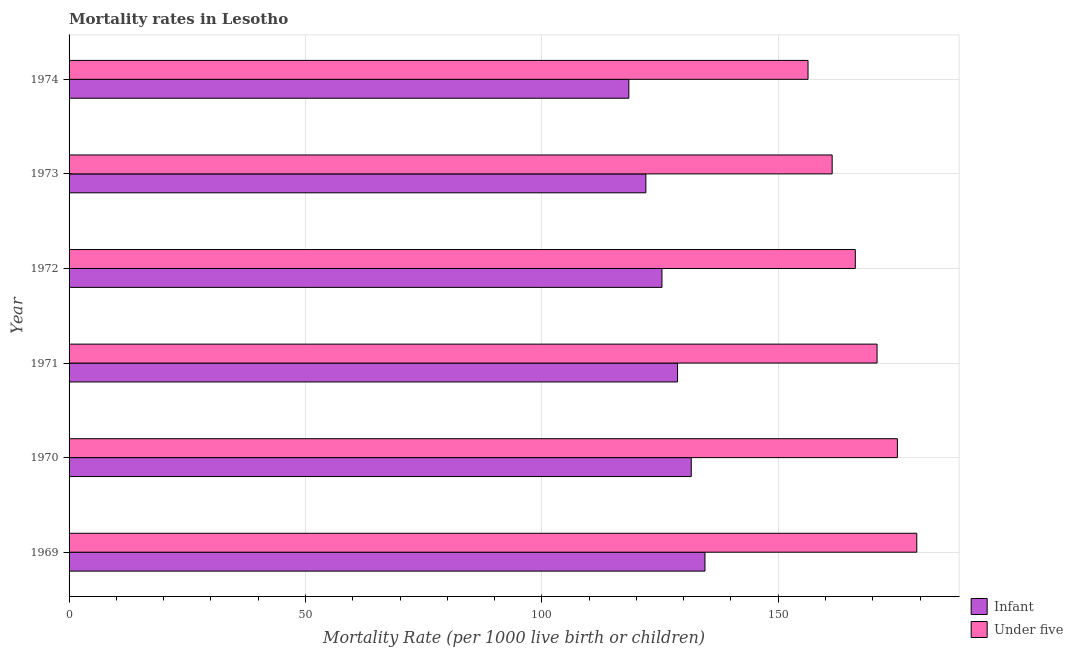Are the number of bars per tick equal to the number of legend labels?
Offer a very short reply. Yes. How many bars are there on the 1st tick from the top?
Offer a very short reply. 2. How many bars are there on the 5th tick from the bottom?
Provide a short and direct response. 2. What is the label of the 1st group of bars from the top?
Provide a short and direct response. 1974. What is the infant mortality rate in 1969?
Ensure brevity in your answer.  134.5. Across all years, what is the maximum under-5 mortality rate?
Offer a terse response. 179.3. Across all years, what is the minimum infant mortality rate?
Offer a terse response. 118.4. In which year was the under-5 mortality rate maximum?
Your answer should be very brief. 1969. In which year was the infant mortality rate minimum?
Your response must be concise. 1974. What is the total infant mortality rate in the graph?
Your answer should be very brief. 760.6. What is the difference between the under-5 mortality rate in 1971 and that in 1972?
Give a very brief answer. 4.6. What is the difference between the under-5 mortality rate in 1969 and the infant mortality rate in 1970?
Make the answer very short. 47.7. What is the average infant mortality rate per year?
Give a very brief answer. 126.77. In the year 1973, what is the difference between the infant mortality rate and under-5 mortality rate?
Provide a succinct answer. -39.4. In how many years, is the infant mortality rate greater than 160 ?
Provide a succinct answer. 0. What is the ratio of the infant mortality rate in 1969 to that in 1974?
Offer a terse response. 1.14. Is the under-5 mortality rate in 1972 less than that in 1973?
Offer a terse response. No. Is the difference between the under-5 mortality rate in 1972 and 1974 greater than the difference between the infant mortality rate in 1972 and 1974?
Offer a terse response. Yes. What is the difference between the highest and the second highest infant mortality rate?
Make the answer very short. 2.9. In how many years, is the under-5 mortality rate greater than the average under-5 mortality rate taken over all years?
Give a very brief answer. 3. What does the 1st bar from the top in 1973 represents?
Offer a terse response. Under five. What does the 2nd bar from the bottom in 1969 represents?
Your response must be concise. Under five. Are all the bars in the graph horizontal?
Your answer should be very brief. Yes. How many years are there in the graph?
Ensure brevity in your answer.  6. What is the difference between two consecutive major ticks on the X-axis?
Ensure brevity in your answer.  50. Does the graph contain any zero values?
Provide a succinct answer. No. Does the graph contain grids?
Offer a very short reply. Yes. Where does the legend appear in the graph?
Offer a terse response. Bottom right. How many legend labels are there?
Your answer should be very brief. 2. How are the legend labels stacked?
Provide a succinct answer. Vertical. What is the title of the graph?
Make the answer very short. Mortality rates in Lesotho. What is the label or title of the X-axis?
Your answer should be very brief. Mortality Rate (per 1000 live birth or children). What is the Mortality Rate (per 1000 live birth or children) in Infant in 1969?
Offer a terse response. 134.5. What is the Mortality Rate (per 1000 live birth or children) of Under five in 1969?
Offer a terse response. 179.3. What is the Mortality Rate (per 1000 live birth or children) in Infant in 1970?
Make the answer very short. 131.6. What is the Mortality Rate (per 1000 live birth or children) in Under five in 1970?
Ensure brevity in your answer.  175.2. What is the Mortality Rate (per 1000 live birth or children) of Infant in 1971?
Keep it short and to the point. 128.7. What is the Mortality Rate (per 1000 live birth or children) in Under five in 1971?
Ensure brevity in your answer.  170.9. What is the Mortality Rate (per 1000 live birth or children) in Infant in 1972?
Your response must be concise. 125.4. What is the Mortality Rate (per 1000 live birth or children) in Under five in 1972?
Offer a very short reply. 166.3. What is the Mortality Rate (per 1000 live birth or children) in Infant in 1973?
Your answer should be compact. 122. What is the Mortality Rate (per 1000 live birth or children) in Under five in 1973?
Your answer should be very brief. 161.4. What is the Mortality Rate (per 1000 live birth or children) in Infant in 1974?
Keep it short and to the point. 118.4. What is the Mortality Rate (per 1000 live birth or children) in Under five in 1974?
Offer a terse response. 156.3. Across all years, what is the maximum Mortality Rate (per 1000 live birth or children) of Infant?
Keep it short and to the point. 134.5. Across all years, what is the maximum Mortality Rate (per 1000 live birth or children) in Under five?
Make the answer very short. 179.3. Across all years, what is the minimum Mortality Rate (per 1000 live birth or children) in Infant?
Offer a terse response. 118.4. Across all years, what is the minimum Mortality Rate (per 1000 live birth or children) in Under five?
Your answer should be very brief. 156.3. What is the total Mortality Rate (per 1000 live birth or children) of Infant in the graph?
Make the answer very short. 760.6. What is the total Mortality Rate (per 1000 live birth or children) in Under five in the graph?
Your response must be concise. 1009.4. What is the difference between the Mortality Rate (per 1000 live birth or children) in Under five in 1969 and that in 1970?
Offer a terse response. 4.1. What is the difference between the Mortality Rate (per 1000 live birth or children) of Infant in 1970 and that in 1971?
Ensure brevity in your answer.  2.9. What is the difference between the Mortality Rate (per 1000 live birth or children) of Under five in 1970 and that in 1971?
Keep it short and to the point. 4.3. What is the difference between the Mortality Rate (per 1000 live birth or children) in Infant in 1970 and that in 1972?
Provide a short and direct response. 6.2. What is the difference between the Mortality Rate (per 1000 live birth or children) in Under five in 1970 and that in 1972?
Ensure brevity in your answer.  8.9. What is the difference between the Mortality Rate (per 1000 live birth or children) of Infant in 1971 and that in 1972?
Offer a terse response. 3.3. What is the difference between the Mortality Rate (per 1000 live birth or children) in Under five in 1971 and that in 1972?
Provide a short and direct response. 4.6. What is the difference between the Mortality Rate (per 1000 live birth or children) of Infant in 1971 and that in 1973?
Give a very brief answer. 6.7. What is the difference between the Mortality Rate (per 1000 live birth or children) of Under five in 1971 and that in 1973?
Keep it short and to the point. 9.5. What is the difference between the Mortality Rate (per 1000 live birth or children) of Infant in 1971 and that in 1974?
Offer a very short reply. 10.3. What is the difference between the Mortality Rate (per 1000 live birth or children) of Under five in 1971 and that in 1974?
Provide a short and direct response. 14.6. What is the difference between the Mortality Rate (per 1000 live birth or children) in Under five in 1972 and that in 1973?
Provide a short and direct response. 4.9. What is the difference between the Mortality Rate (per 1000 live birth or children) in Infant in 1972 and that in 1974?
Provide a succinct answer. 7. What is the difference between the Mortality Rate (per 1000 live birth or children) in Under five in 1972 and that in 1974?
Provide a succinct answer. 10. What is the difference between the Mortality Rate (per 1000 live birth or children) in Infant in 1973 and that in 1974?
Keep it short and to the point. 3.6. What is the difference between the Mortality Rate (per 1000 live birth or children) in Under five in 1973 and that in 1974?
Give a very brief answer. 5.1. What is the difference between the Mortality Rate (per 1000 live birth or children) of Infant in 1969 and the Mortality Rate (per 1000 live birth or children) of Under five in 1970?
Your response must be concise. -40.7. What is the difference between the Mortality Rate (per 1000 live birth or children) of Infant in 1969 and the Mortality Rate (per 1000 live birth or children) of Under five in 1971?
Ensure brevity in your answer.  -36.4. What is the difference between the Mortality Rate (per 1000 live birth or children) in Infant in 1969 and the Mortality Rate (per 1000 live birth or children) in Under five in 1972?
Provide a succinct answer. -31.8. What is the difference between the Mortality Rate (per 1000 live birth or children) of Infant in 1969 and the Mortality Rate (per 1000 live birth or children) of Under five in 1973?
Offer a terse response. -26.9. What is the difference between the Mortality Rate (per 1000 live birth or children) in Infant in 1969 and the Mortality Rate (per 1000 live birth or children) in Under five in 1974?
Ensure brevity in your answer.  -21.8. What is the difference between the Mortality Rate (per 1000 live birth or children) in Infant in 1970 and the Mortality Rate (per 1000 live birth or children) in Under five in 1971?
Give a very brief answer. -39.3. What is the difference between the Mortality Rate (per 1000 live birth or children) in Infant in 1970 and the Mortality Rate (per 1000 live birth or children) in Under five in 1972?
Offer a terse response. -34.7. What is the difference between the Mortality Rate (per 1000 live birth or children) of Infant in 1970 and the Mortality Rate (per 1000 live birth or children) of Under five in 1973?
Offer a terse response. -29.8. What is the difference between the Mortality Rate (per 1000 live birth or children) of Infant in 1970 and the Mortality Rate (per 1000 live birth or children) of Under five in 1974?
Make the answer very short. -24.7. What is the difference between the Mortality Rate (per 1000 live birth or children) in Infant in 1971 and the Mortality Rate (per 1000 live birth or children) in Under five in 1972?
Your answer should be compact. -37.6. What is the difference between the Mortality Rate (per 1000 live birth or children) in Infant in 1971 and the Mortality Rate (per 1000 live birth or children) in Under five in 1973?
Your answer should be very brief. -32.7. What is the difference between the Mortality Rate (per 1000 live birth or children) of Infant in 1971 and the Mortality Rate (per 1000 live birth or children) of Under five in 1974?
Keep it short and to the point. -27.6. What is the difference between the Mortality Rate (per 1000 live birth or children) of Infant in 1972 and the Mortality Rate (per 1000 live birth or children) of Under five in 1973?
Provide a short and direct response. -36. What is the difference between the Mortality Rate (per 1000 live birth or children) of Infant in 1972 and the Mortality Rate (per 1000 live birth or children) of Under five in 1974?
Offer a very short reply. -30.9. What is the difference between the Mortality Rate (per 1000 live birth or children) in Infant in 1973 and the Mortality Rate (per 1000 live birth or children) in Under five in 1974?
Offer a terse response. -34.3. What is the average Mortality Rate (per 1000 live birth or children) of Infant per year?
Give a very brief answer. 126.77. What is the average Mortality Rate (per 1000 live birth or children) in Under five per year?
Offer a very short reply. 168.23. In the year 1969, what is the difference between the Mortality Rate (per 1000 live birth or children) of Infant and Mortality Rate (per 1000 live birth or children) of Under five?
Provide a succinct answer. -44.8. In the year 1970, what is the difference between the Mortality Rate (per 1000 live birth or children) in Infant and Mortality Rate (per 1000 live birth or children) in Under five?
Give a very brief answer. -43.6. In the year 1971, what is the difference between the Mortality Rate (per 1000 live birth or children) in Infant and Mortality Rate (per 1000 live birth or children) in Under five?
Make the answer very short. -42.2. In the year 1972, what is the difference between the Mortality Rate (per 1000 live birth or children) in Infant and Mortality Rate (per 1000 live birth or children) in Under five?
Give a very brief answer. -40.9. In the year 1973, what is the difference between the Mortality Rate (per 1000 live birth or children) in Infant and Mortality Rate (per 1000 live birth or children) in Under five?
Offer a very short reply. -39.4. In the year 1974, what is the difference between the Mortality Rate (per 1000 live birth or children) of Infant and Mortality Rate (per 1000 live birth or children) of Under five?
Your answer should be very brief. -37.9. What is the ratio of the Mortality Rate (per 1000 live birth or children) of Under five in 1969 to that in 1970?
Keep it short and to the point. 1.02. What is the ratio of the Mortality Rate (per 1000 live birth or children) of Infant in 1969 to that in 1971?
Give a very brief answer. 1.05. What is the ratio of the Mortality Rate (per 1000 live birth or children) in Under five in 1969 to that in 1971?
Keep it short and to the point. 1.05. What is the ratio of the Mortality Rate (per 1000 live birth or children) of Infant in 1969 to that in 1972?
Ensure brevity in your answer.  1.07. What is the ratio of the Mortality Rate (per 1000 live birth or children) of Under five in 1969 to that in 1972?
Give a very brief answer. 1.08. What is the ratio of the Mortality Rate (per 1000 live birth or children) of Infant in 1969 to that in 1973?
Make the answer very short. 1.1. What is the ratio of the Mortality Rate (per 1000 live birth or children) of Under five in 1969 to that in 1973?
Keep it short and to the point. 1.11. What is the ratio of the Mortality Rate (per 1000 live birth or children) in Infant in 1969 to that in 1974?
Your answer should be very brief. 1.14. What is the ratio of the Mortality Rate (per 1000 live birth or children) in Under five in 1969 to that in 1974?
Offer a terse response. 1.15. What is the ratio of the Mortality Rate (per 1000 live birth or children) in Infant in 1970 to that in 1971?
Give a very brief answer. 1.02. What is the ratio of the Mortality Rate (per 1000 live birth or children) in Under five in 1970 to that in 1971?
Your answer should be very brief. 1.03. What is the ratio of the Mortality Rate (per 1000 live birth or children) in Infant in 1970 to that in 1972?
Your answer should be very brief. 1.05. What is the ratio of the Mortality Rate (per 1000 live birth or children) of Under five in 1970 to that in 1972?
Keep it short and to the point. 1.05. What is the ratio of the Mortality Rate (per 1000 live birth or children) of Infant in 1970 to that in 1973?
Ensure brevity in your answer.  1.08. What is the ratio of the Mortality Rate (per 1000 live birth or children) of Under five in 1970 to that in 1973?
Your answer should be very brief. 1.09. What is the ratio of the Mortality Rate (per 1000 live birth or children) of Infant in 1970 to that in 1974?
Ensure brevity in your answer.  1.11. What is the ratio of the Mortality Rate (per 1000 live birth or children) of Under five in 1970 to that in 1974?
Your answer should be compact. 1.12. What is the ratio of the Mortality Rate (per 1000 live birth or children) of Infant in 1971 to that in 1972?
Make the answer very short. 1.03. What is the ratio of the Mortality Rate (per 1000 live birth or children) of Under five in 1971 to that in 1972?
Your answer should be very brief. 1.03. What is the ratio of the Mortality Rate (per 1000 live birth or children) in Infant in 1971 to that in 1973?
Offer a terse response. 1.05. What is the ratio of the Mortality Rate (per 1000 live birth or children) in Under five in 1971 to that in 1973?
Provide a short and direct response. 1.06. What is the ratio of the Mortality Rate (per 1000 live birth or children) of Infant in 1971 to that in 1974?
Ensure brevity in your answer.  1.09. What is the ratio of the Mortality Rate (per 1000 live birth or children) in Under five in 1971 to that in 1974?
Your answer should be compact. 1.09. What is the ratio of the Mortality Rate (per 1000 live birth or children) of Infant in 1972 to that in 1973?
Offer a very short reply. 1.03. What is the ratio of the Mortality Rate (per 1000 live birth or children) of Under five in 1972 to that in 1973?
Your answer should be very brief. 1.03. What is the ratio of the Mortality Rate (per 1000 live birth or children) of Infant in 1972 to that in 1974?
Keep it short and to the point. 1.06. What is the ratio of the Mortality Rate (per 1000 live birth or children) in Under five in 1972 to that in 1974?
Keep it short and to the point. 1.06. What is the ratio of the Mortality Rate (per 1000 live birth or children) in Infant in 1973 to that in 1974?
Your answer should be compact. 1.03. What is the ratio of the Mortality Rate (per 1000 live birth or children) of Under five in 1973 to that in 1974?
Your answer should be compact. 1.03. What is the difference between the highest and the second highest Mortality Rate (per 1000 live birth or children) of Under five?
Provide a succinct answer. 4.1. What is the difference between the highest and the lowest Mortality Rate (per 1000 live birth or children) in Under five?
Make the answer very short. 23. 